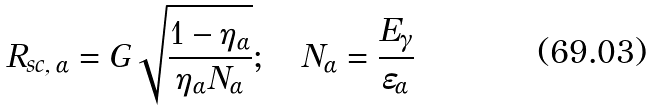Convert formula to latex. <formula><loc_0><loc_0><loc_500><loc_500>R _ { s c , \, \alpha } = G \sqrt { { \frac { { 1 - \eta _ { \alpha } } } { { \eta _ { \alpha } N _ { \alpha } } } } } ; \quad N _ { \alpha } = { \frac { { E _ { \gamma } } } { { \varepsilon _ { \alpha } } } }</formula> 